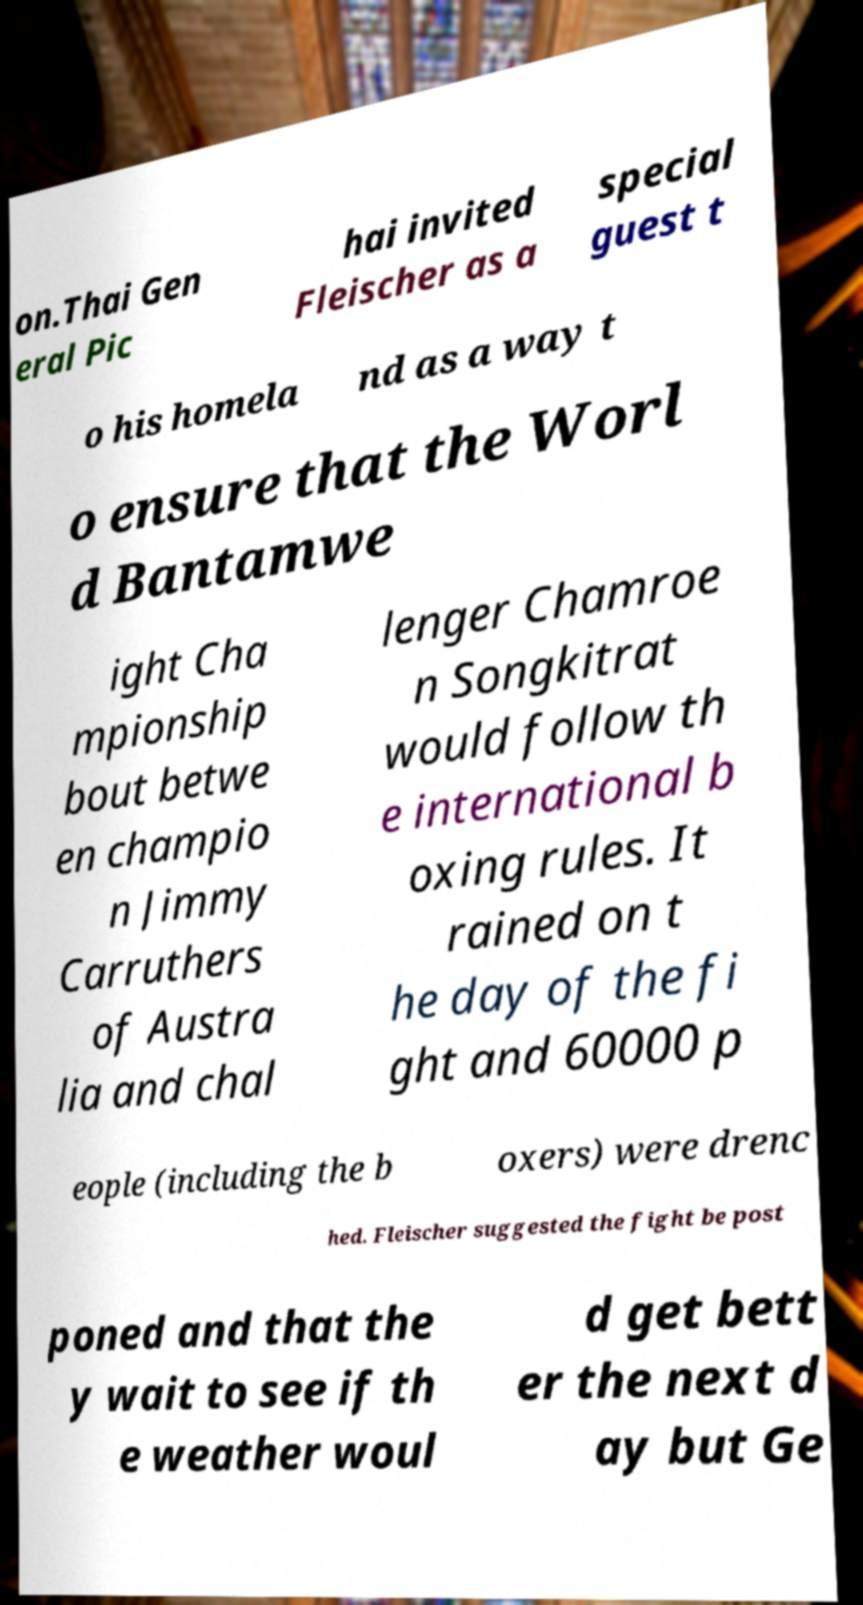I need the written content from this picture converted into text. Can you do that? on.Thai Gen eral Pic hai invited Fleischer as a special guest t o his homela nd as a way t o ensure that the Worl d Bantamwe ight Cha mpionship bout betwe en champio n Jimmy Carruthers of Austra lia and chal lenger Chamroe n Songkitrat would follow th e international b oxing rules. It rained on t he day of the fi ght and 60000 p eople (including the b oxers) were drenc hed. Fleischer suggested the fight be post poned and that the y wait to see if th e weather woul d get bett er the next d ay but Ge 